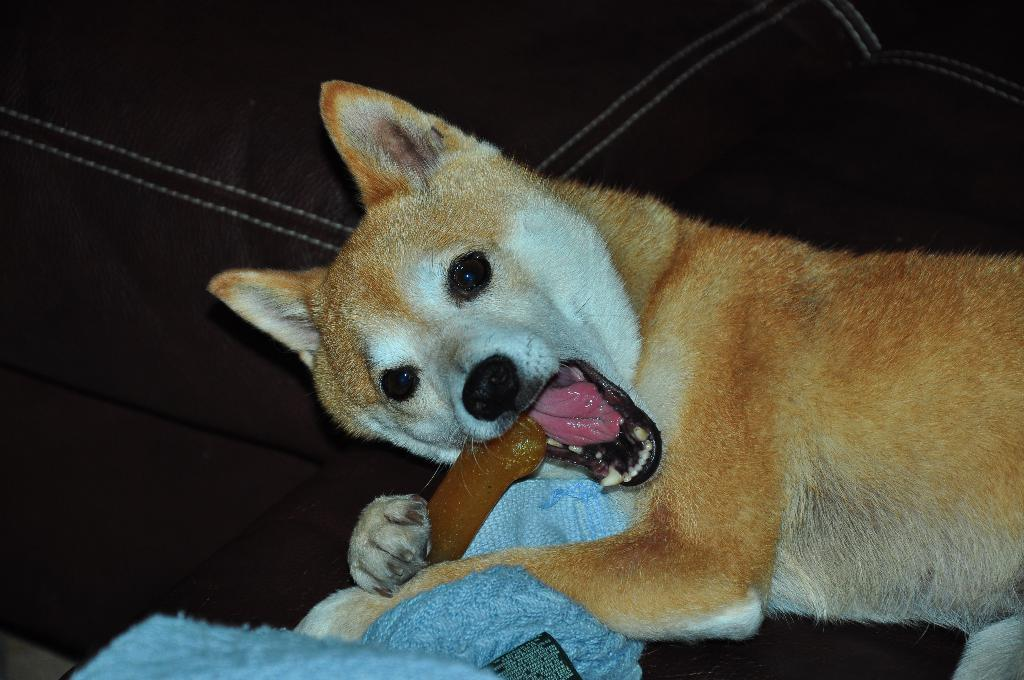What type of animal can be seen in the image? There is an animal in the image, but its specific type cannot be determined from the provided facts. What is the animal doing in the image? The animal is biting an object in the image. What color is the background of the image? The background of the image is black. What can be seen at the bottom of the image? There is a blue colored object at the bottom of the image. What is the level of friction between the orange and the boundary in the image? There is no orange or boundary present in the image, so it is not possible to determine the level of friction between them. 